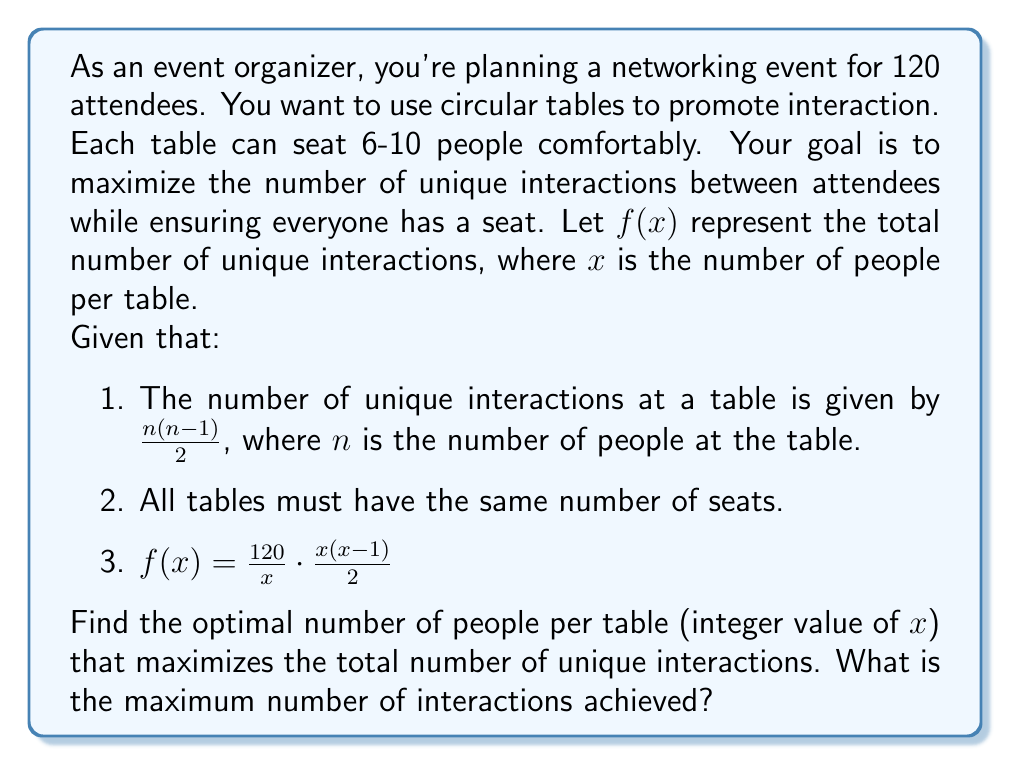Give your solution to this math problem. To solve this problem, we'll follow these steps:

1) First, let's simplify the function $f(x)$:
   $$f(x) = \frac{120}{x} \cdot \frac{x(x-1)}{2} = 60(x-1)$$

2) This is a linear function, but we need to remember our constraints:
   - $x$ must be an integer
   - $6 \leq x \leq 10$
   - $120$ must be divisible by $x$

3) Let's evaluate $f(x)$ for all possible values of $x$:

   For $x = 6$: $f(6) = 60(6-1) = 300$
   For $x = 8$: $f(8) = 60(8-1) = 420$
   For $x = 10$: $f(10) = 60(10-1) = 540$

   Note that $x = 7$ and $x = 9$ are not valid because 120 is not divisible by these numbers.

4) Among the valid options, $x = 10$ gives the maximum value of $f(x)$.

5) To calculate the total number of interactions:
   With 10 people per table, there will be 12 tables.
   Each table will have $\frac{10(10-1)}{2} = 45$ interactions.
   Total interactions = $12 \cdot 45 = 540$

Therefore, the optimal arrangement is to have 12 tables with 10 people each, resulting in 540 unique interactions.
Answer: The optimal number of people per table is 10, achieving a maximum of 540 unique interactions. 